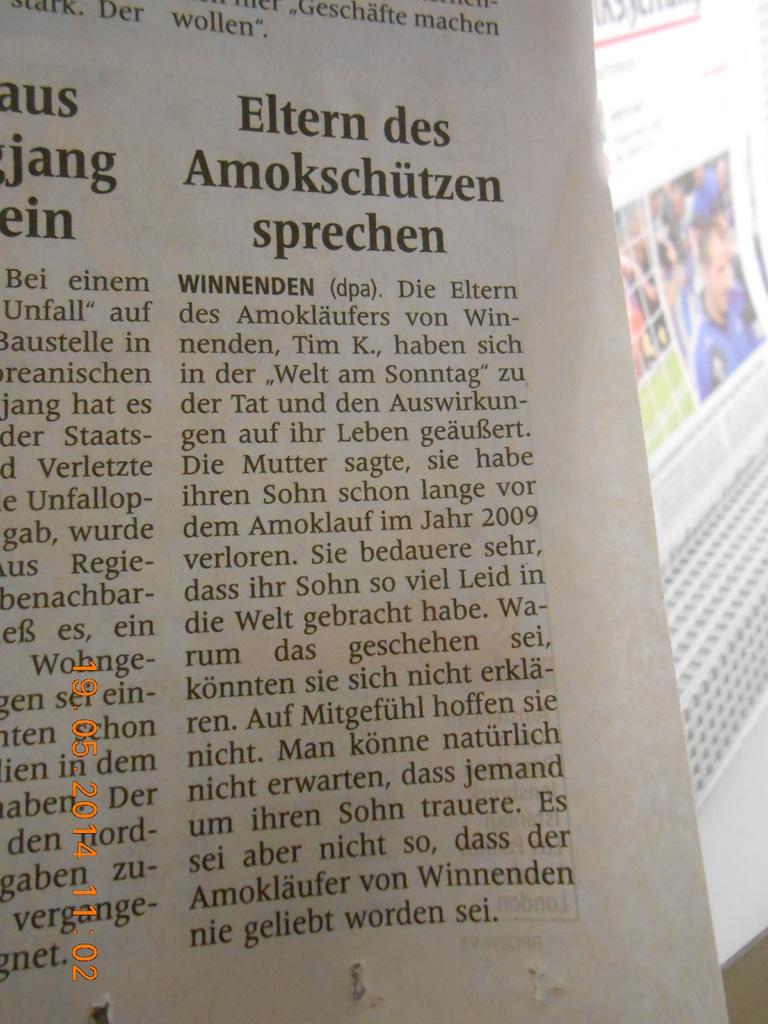What is the title of one of the articles?
Offer a terse response. Eltern des amokschutzen sprechen. 